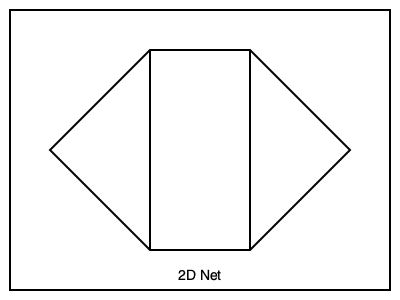Which 3D shape would be formed if you folded the given 2D net along its lines? Think about how the sides would come together to create a three-dimensional object. Let's analyze the 2D net step-by-step to determine the 3D shape it would form:

1. Count the faces: The net shows 6 faces in total.

2. Identify the shape of the faces:
   - The top and bottom faces are hexagons.
   - The four side faces are rectangles.

3. Visualize the folding process:
   - The four rectangles would fold up to form the sides of the shape.
   - The two hexagons would remain parallel to each other, forming the top and bottom.

4. Consider the resulting 3D shape:
   - A shape with two parallel hexagonal faces connected by rectangular sides is called a hexagonal prism.

5. Verify the properties:
   - A hexagonal prism has 6 faces (2 hexagonal bases and 4 rectangular sides).
   - It has 12 edges (6 on each hexagonal base, and 6 connecting the bases).
   - It has 12 vertices (6 on each hexagonal base).

These properties match what we can observe from the given 2D net.
Answer: Hexagonal prism 